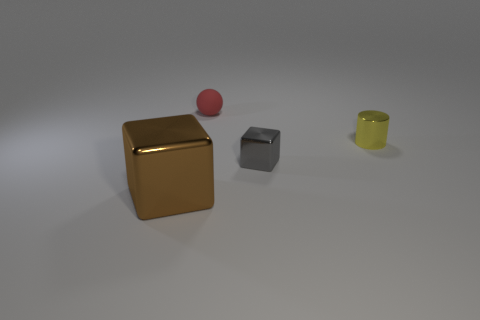There is a shiny block that is behind the cube that is in front of the cube that is right of the rubber object; what is its color?
Your answer should be compact. Gray. What number of things are both on the left side of the tiny yellow object and behind the gray metal object?
Provide a short and direct response. 1. There is a small thing that is behind the tiny yellow shiny cylinder; is it the same color as the block that is behind the big brown shiny cube?
Ensure brevity in your answer.  No. Are there any other things that are the same material as the big thing?
Offer a terse response. Yes. What size is the brown metal thing that is the same shape as the tiny gray shiny object?
Keep it short and to the point. Large. There is a red rubber thing; are there any tiny red rubber things left of it?
Your answer should be very brief. No. Are there the same number of big shiny things that are behind the big metallic thing and small things?
Provide a succinct answer. No. There is a brown block that is left of the small shiny object that is in front of the yellow metal cylinder; is there a yellow object that is to the left of it?
Your answer should be very brief. No. What is the small yellow cylinder made of?
Give a very brief answer. Metal. How many other objects are the same shape as the big brown shiny thing?
Ensure brevity in your answer.  1. 